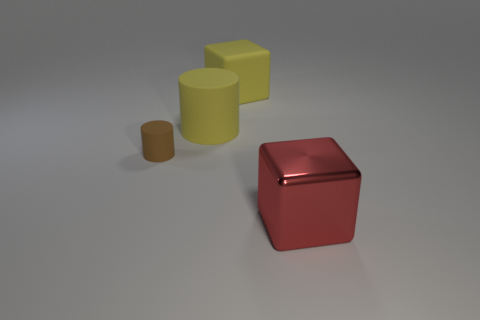Is there anything else that is the same material as the tiny brown cylinder?
Your answer should be compact. Yes. There is a big shiny thing; are there any large objects to the left of it?
Your response must be concise. Yes. What number of purple metallic objects are there?
Give a very brief answer. 0. What number of large yellow rubber cylinders are to the right of the yellow object left of the matte cube?
Your response must be concise. 0. There is a big matte block; is it the same color as the matte cylinder on the right side of the small brown object?
Your response must be concise. Yes. How many other shiny objects are the same shape as the red thing?
Ensure brevity in your answer.  0. There is a big block in front of the big rubber cube; what is it made of?
Keep it short and to the point. Metal. There is a yellow rubber object that is behind the yellow rubber cylinder; does it have the same shape as the big shiny thing?
Ensure brevity in your answer.  Yes. Is there a yellow cube of the same size as the yellow rubber cylinder?
Make the answer very short. Yes. Does the tiny rubber object have the same shape as the big shiny object in front of the brown rubber cylinder?
Keep it short and to the point. No. 